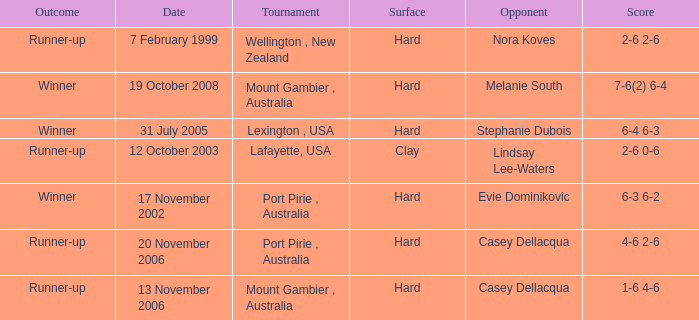Which Score has an Opponent of melanie south? 7-6(2) 6-4. 